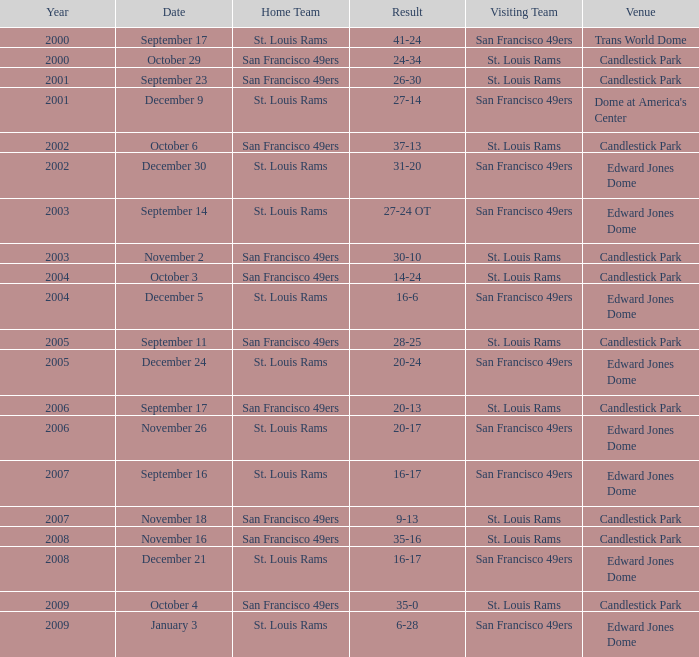What is the location of the 2009 st. louis rams home match? Edward Jones Dome. 